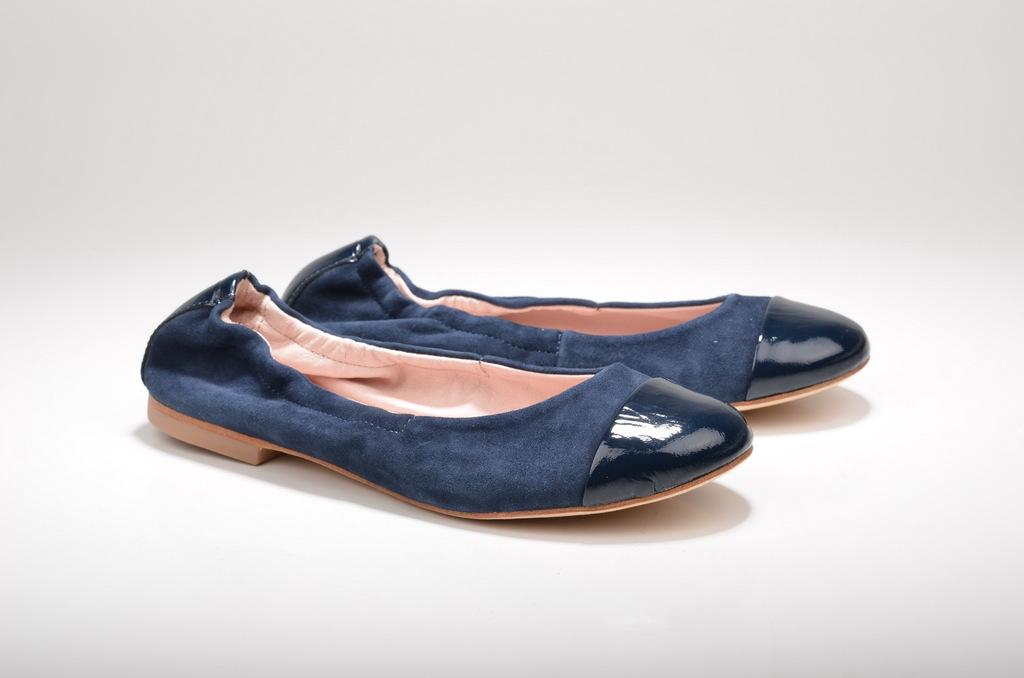What type of object is present in the image? There is footwear in the image. What colors can be seen on the footwear? The footwear has blue and black colors. What color is the background of the image? The background of the image is white. What type of sign can be seen on the footwear in the image? There is no sign present on the footwear in the image. Can you see a monkey interacting with the footwear in the image? There is no monkey present in the image. 